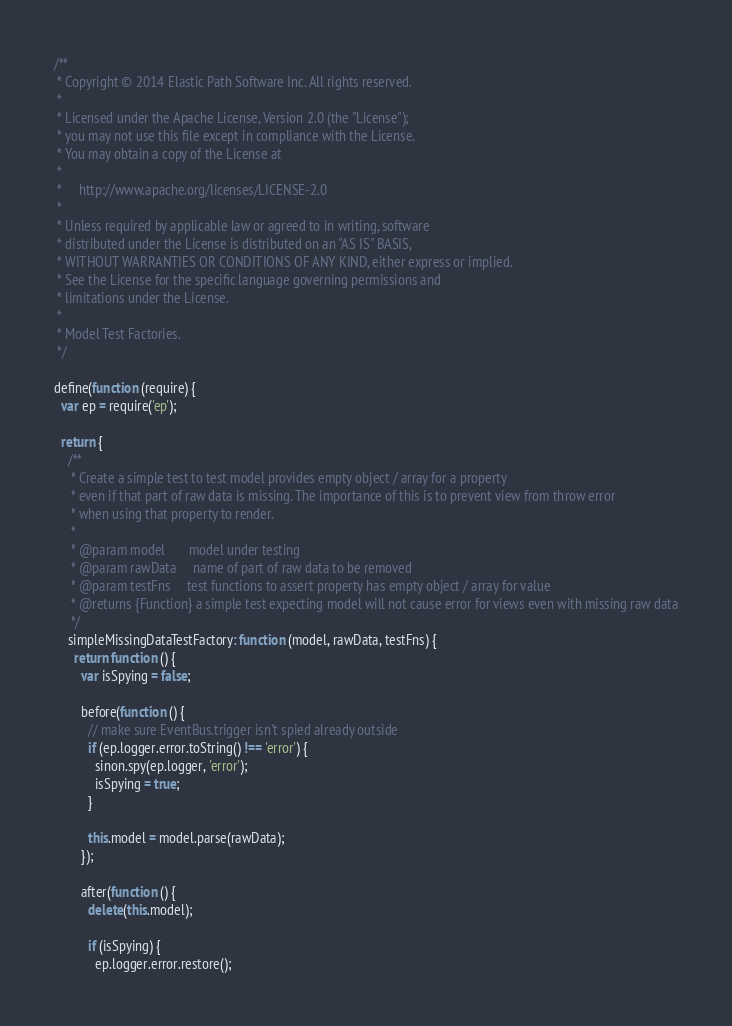Convert code to text. <code><loc_0><loc_0><loc_500><loc_500><_JavaScript_>/**
 * Copyright © 2014 Elastic Path Software Inc. All rights reserved.
 *
 * Licensed under the Apache License, Version 2.0 (the "License");
 * you may not use this file except in compliance with the License.
 * You may obtain a copy of the License at
 *
 *     http://www.apache.org/licenses/LICENSE-2.0
 *
 * Unless required by applicable law or agreed to in writing, software
 * distributed under the License is distributed on an "AS IS" BASIS,
 * WITHOUT WARRANTIES OR CONDITIONS OF ANY KIND, either express or implied.
 * See the License for the specific language governing permissions and
 * limitations under the License.
 *
 * Model Test Factories.
 */

define(function (require) {
  var ep = require('ep');

  return {
    /**
     * Create a simple test to test model provides empty object / array for a property
     * even if that part of raw data is missing. The importance of this is to prevent view from throw error
     * when using that property to render.
     *
     * @param model       model under testing
     * @param rawData     name of part of raw data to be removed
     * @param testFns     test functions to assert property has empty object / array for value
     * @returns {Function} a simple test expecting model will not cause error for views even with missing raw data
     */
    simpleMissingDataTestFactory: function (model, rawData, testFns) {
      return function () {
        var isSpying = false;

        before(function () {
          // make sure EventBus.trigger isn't spied already outside
          if (ep.logger.error.toString() !== 'error') {
            sinon.spy(ep.logger, 'error');
            isSpying = true;
          }

          this.model = model.parse(rawData);
        });

        after(function () {
          delete(this.model);

          if (isSpying) {
            ep.logger.error.restore();</code> 